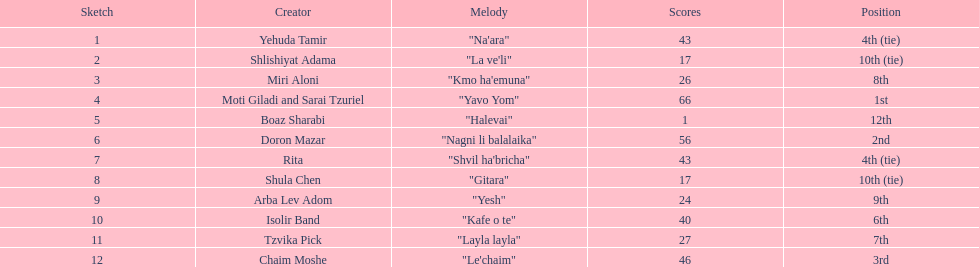How many artists are there? Yehuda Tamir, Shlishiyat Adama, Miri Aloni, Moti Giladi and Sarai Tzuriel, Boaz Sharabi, Doron Mazar, Rita, Shula Chen, Arba Lev Adom, Isolir Band, Tzvika Pick, Chaim Moshe. What is the least amount of points awarded? 1. Who was the artist awarded those points? Boaz Sharabi. 